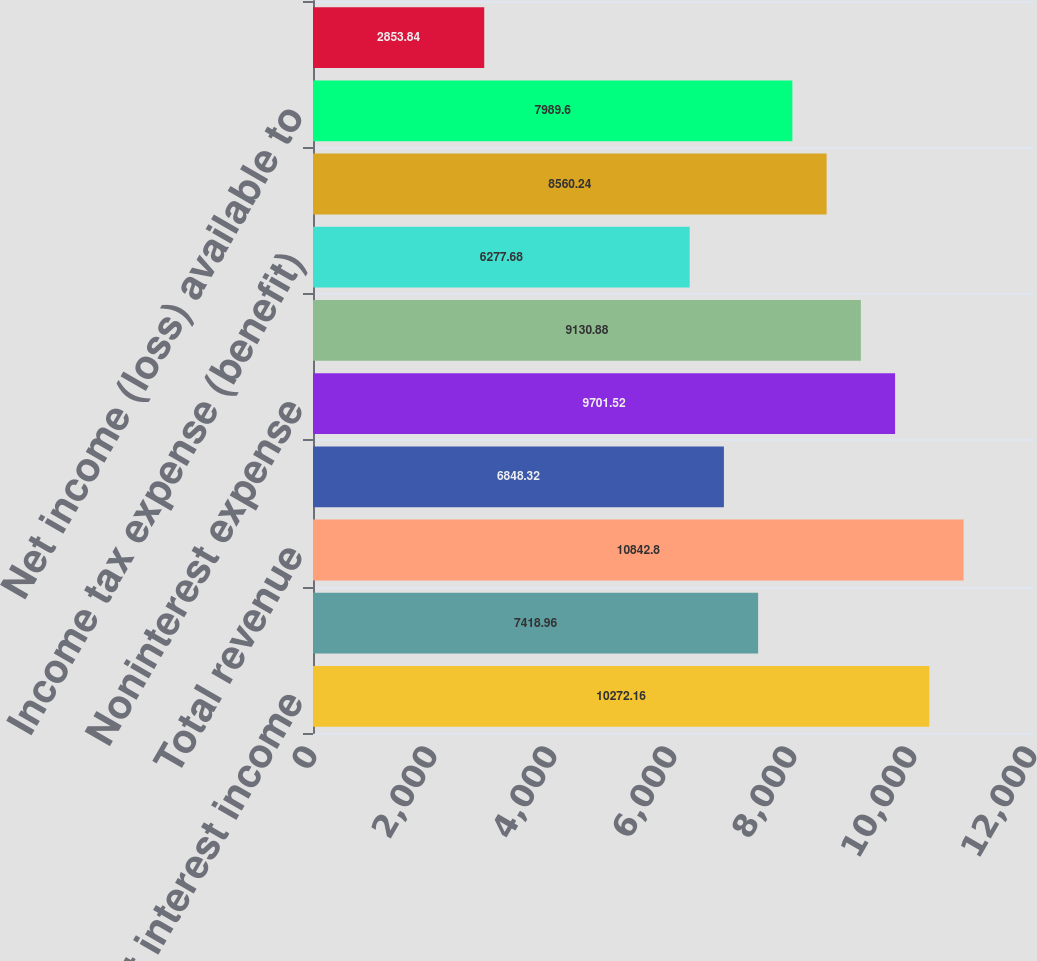Convert chart to OTSL. <chart><loc_0><loc_0><loc_500><loc_500><bar_chart><fcel>Net interest income<fcel>Noninterest income<fcel>Total revenue<fcel>Provision for credit losses<fcel>Noninterest expense<fcel>Income (loss) before income<fcel>Income tax expense (benefit)<fcel>Net income (loss)<fcel>Net income (loss) available to<fcel>Net income (loss) per average<nl><fcel>10272.2<fcel>7418.96<fcel>10842.8<fcel>6848.32<fcel>9701.52<fcel>9130.88<fcel>6277.68<fcel>8560.24<fcel>7989.6<fcel>2853.84<nl></chart> 